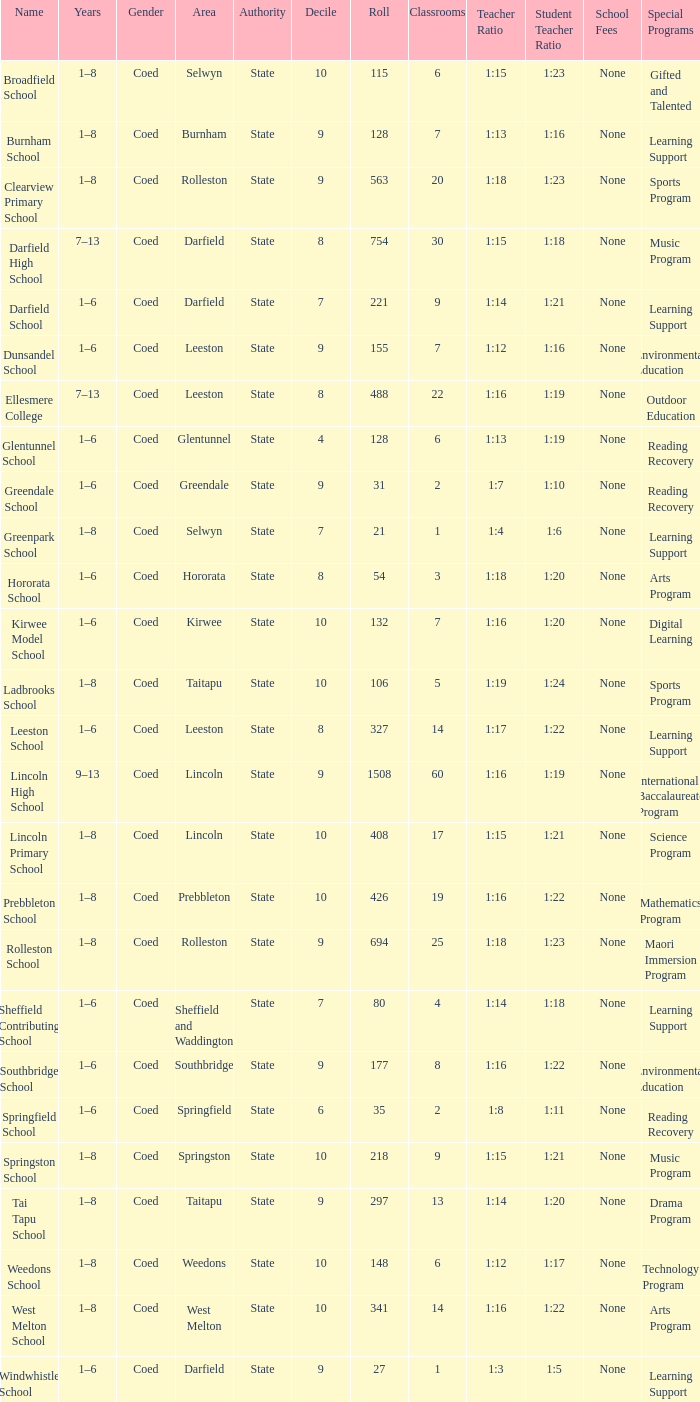Which name has a Roll larger than 297, and Years of 7–13? Darfield High School, Ellesmere College. 